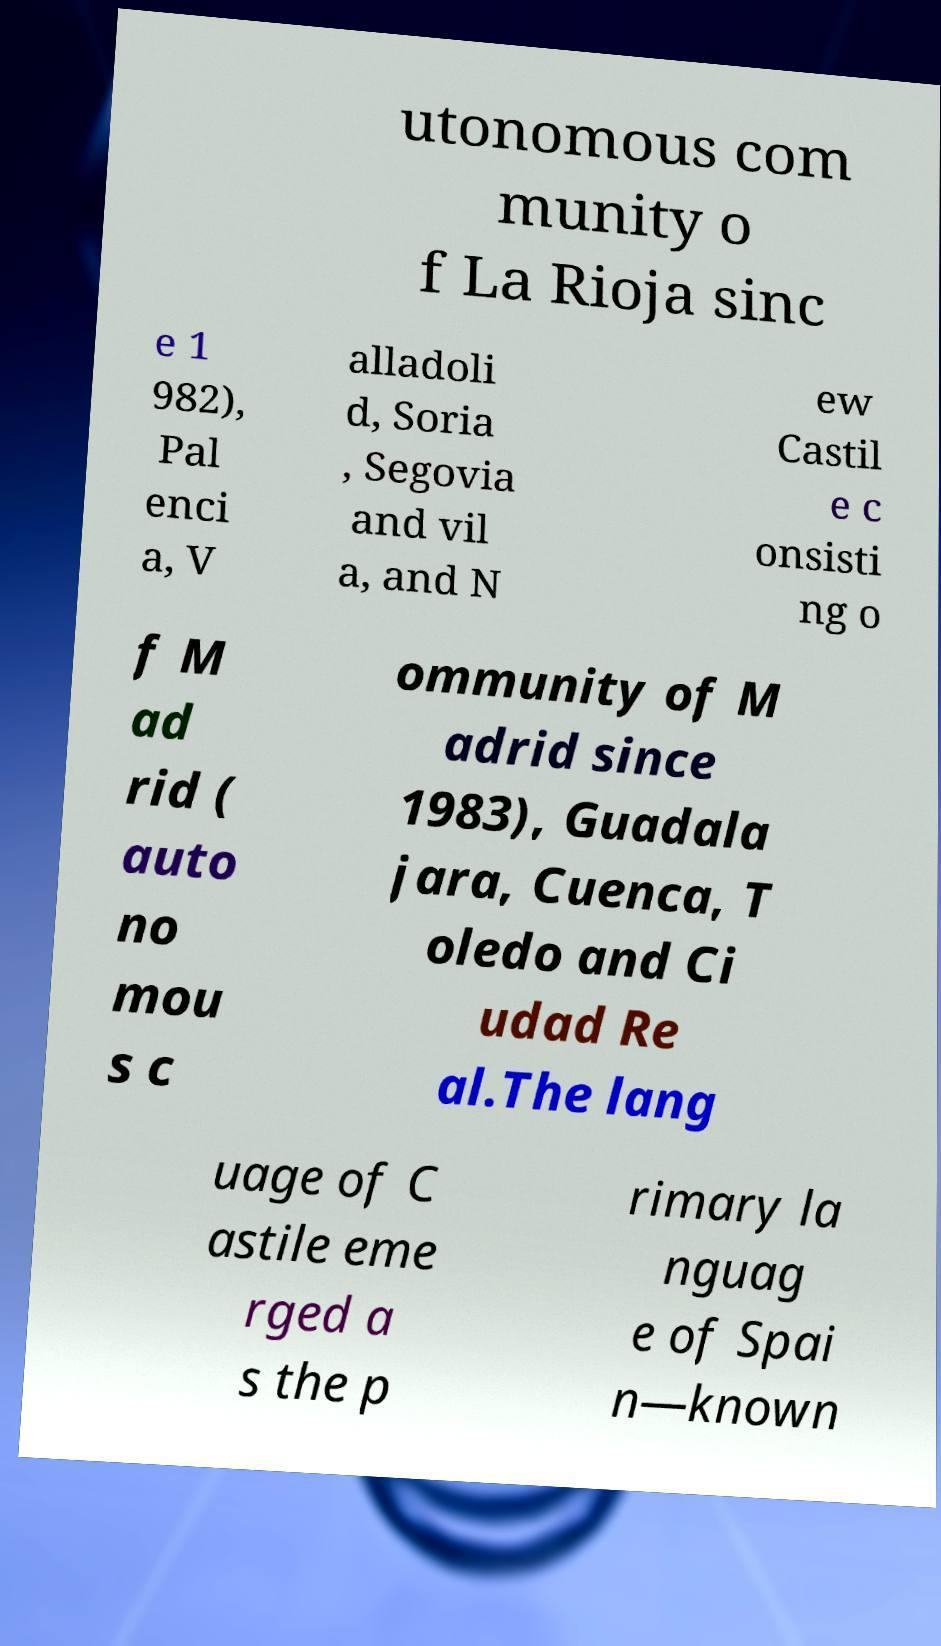Can you accurately transcribe the text from the provided image for me? utonomous com munity o f La Rioja sinc e 1 982), Pal enci a, V alladoli d, Soria , Segovia and vil a, and N ew Castil e c onsisti ng o f M ad rid ( auto no mou s c ommunity of M adrid since 1983), Guadala jara, Cuenca, T oledo and Ci udad Re al.The lang uage of C astile eme rged a s the p rimary la nguag e of Spai n—known 